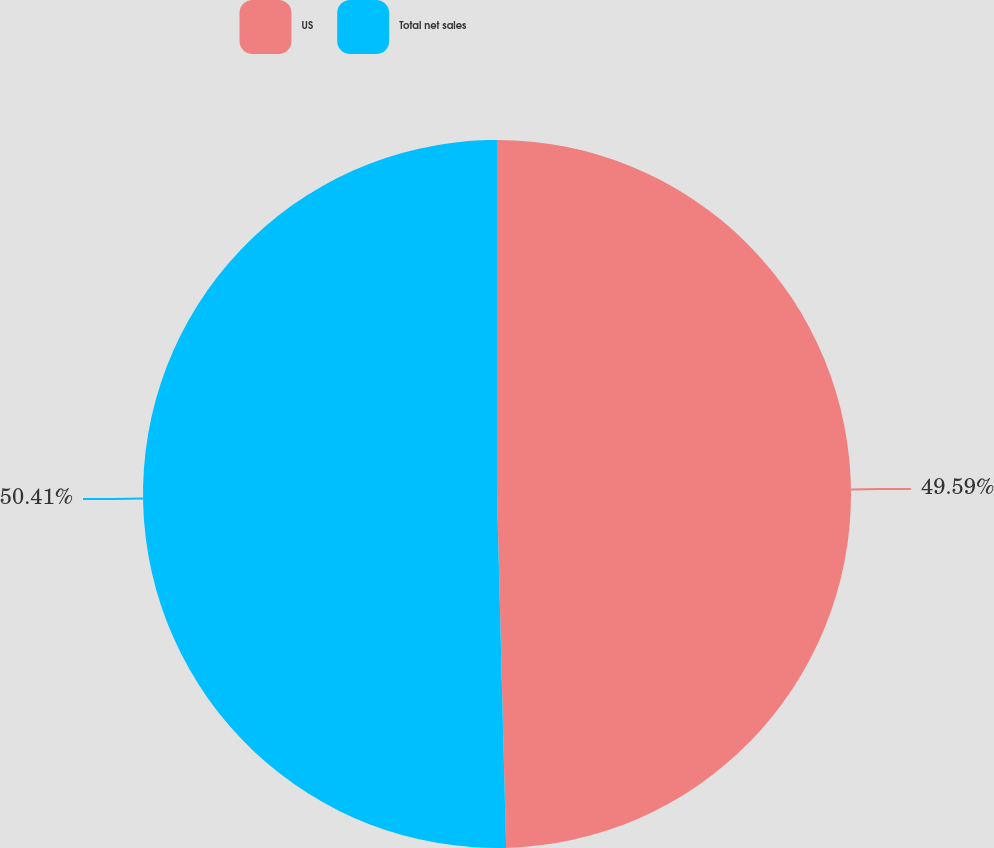Convert chart to OTSL. <chart><loc_0><loc_0><loc_500><loc_500><pie_chart><fcel>US<fcel>Total net sales<nl><fcel>49.59%<fcel>50.41%<nl></chart> 